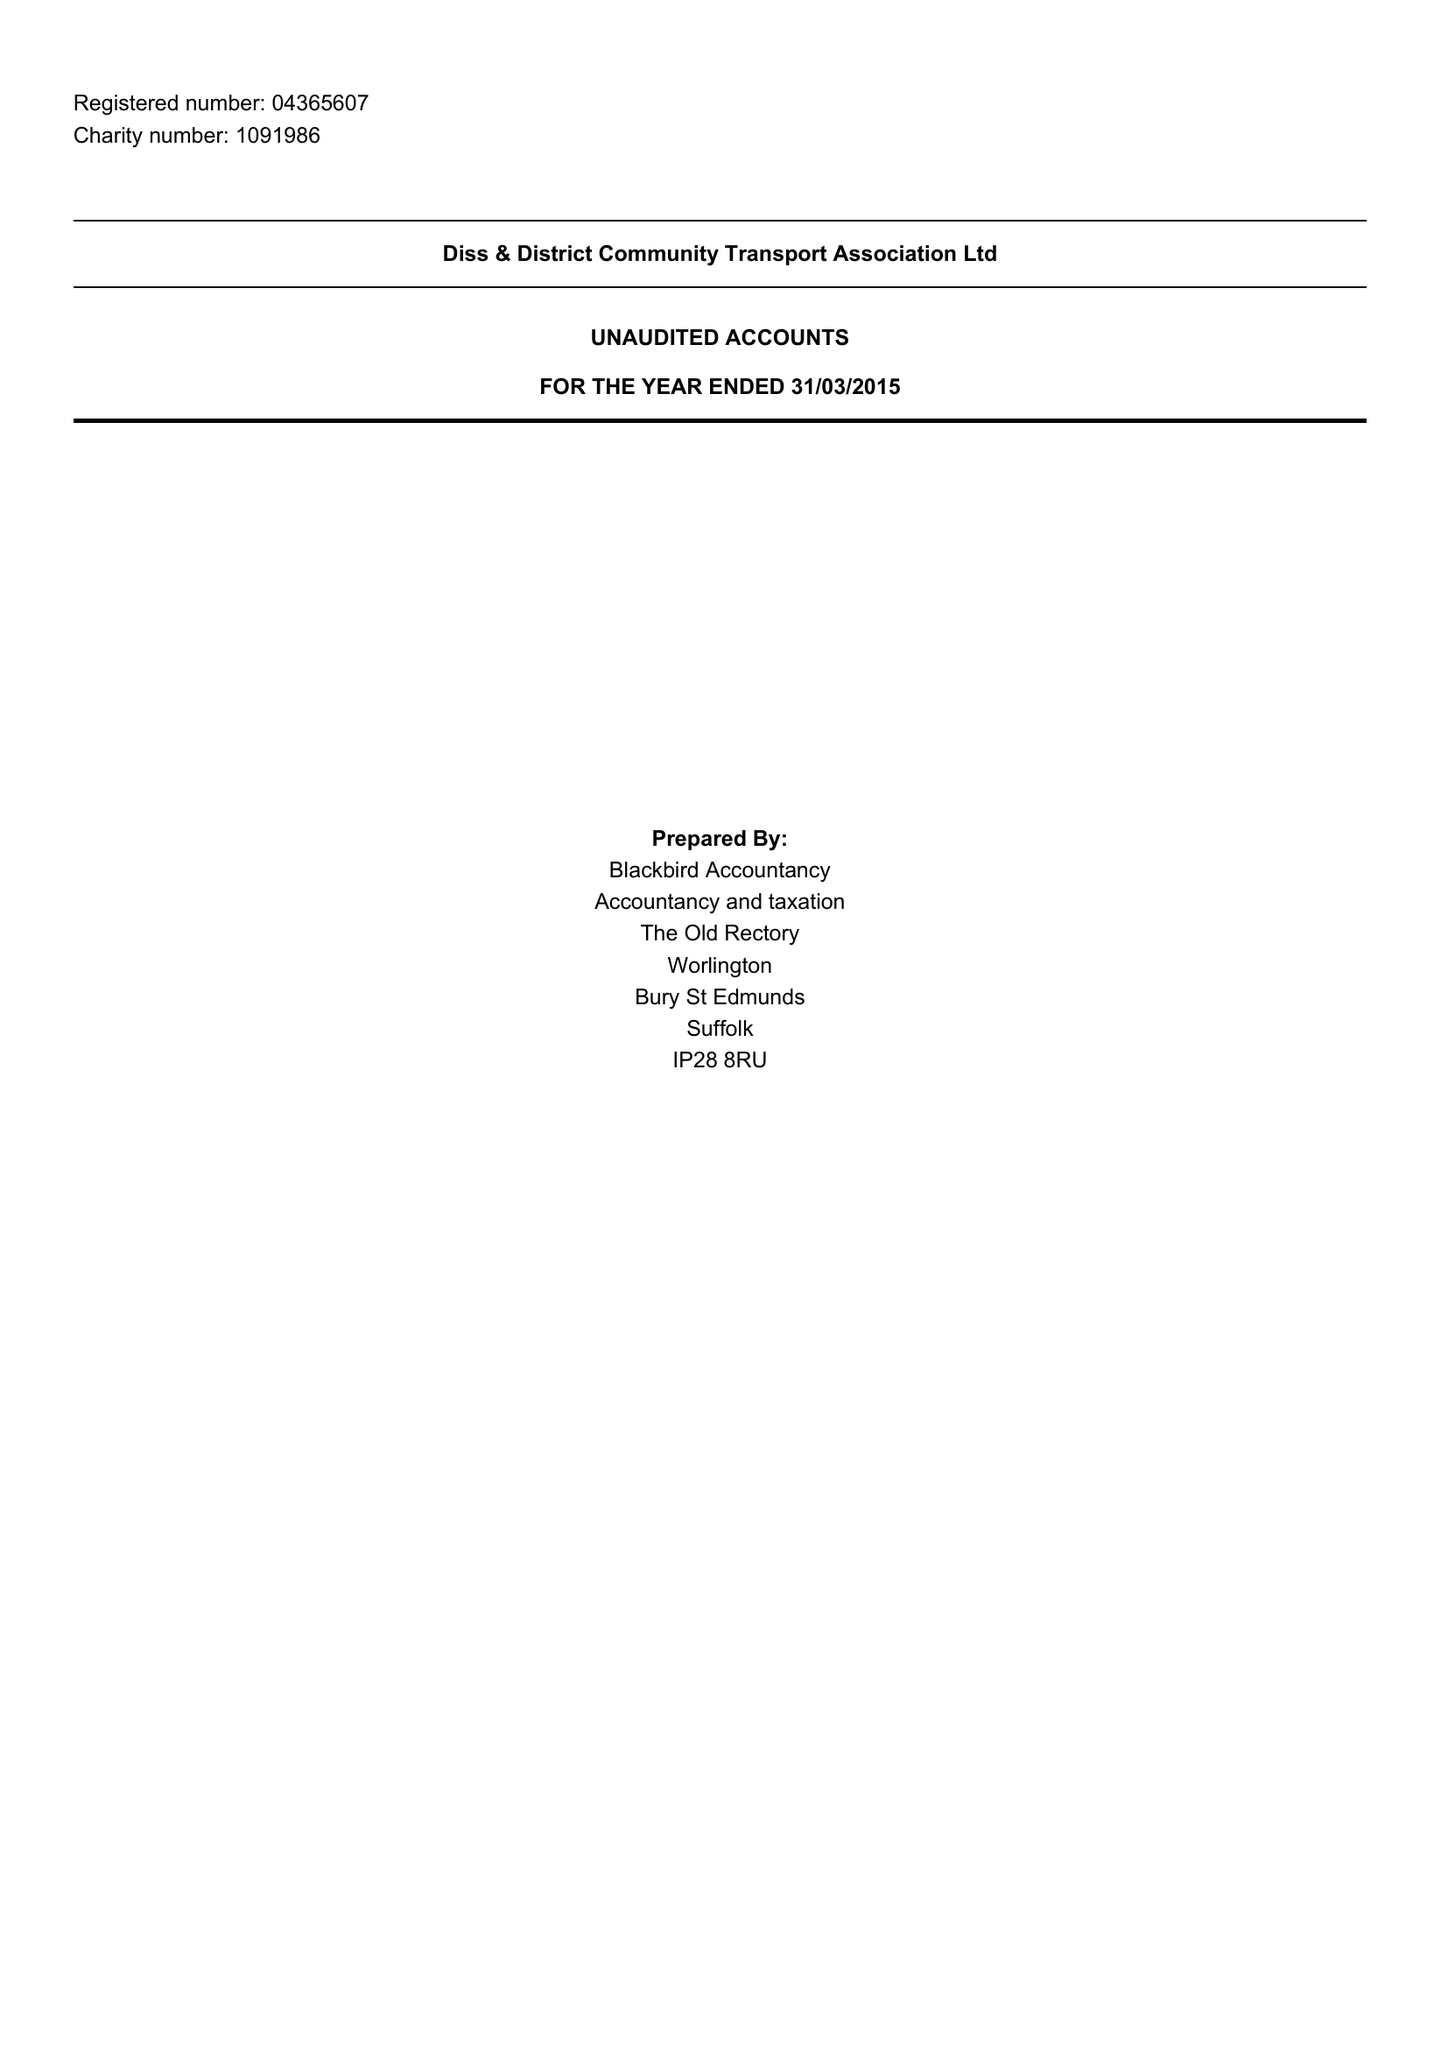What is the value for the charity_name?
Answer the question using a single word or phrase. Diss and District Community Transport Association Ltd. 